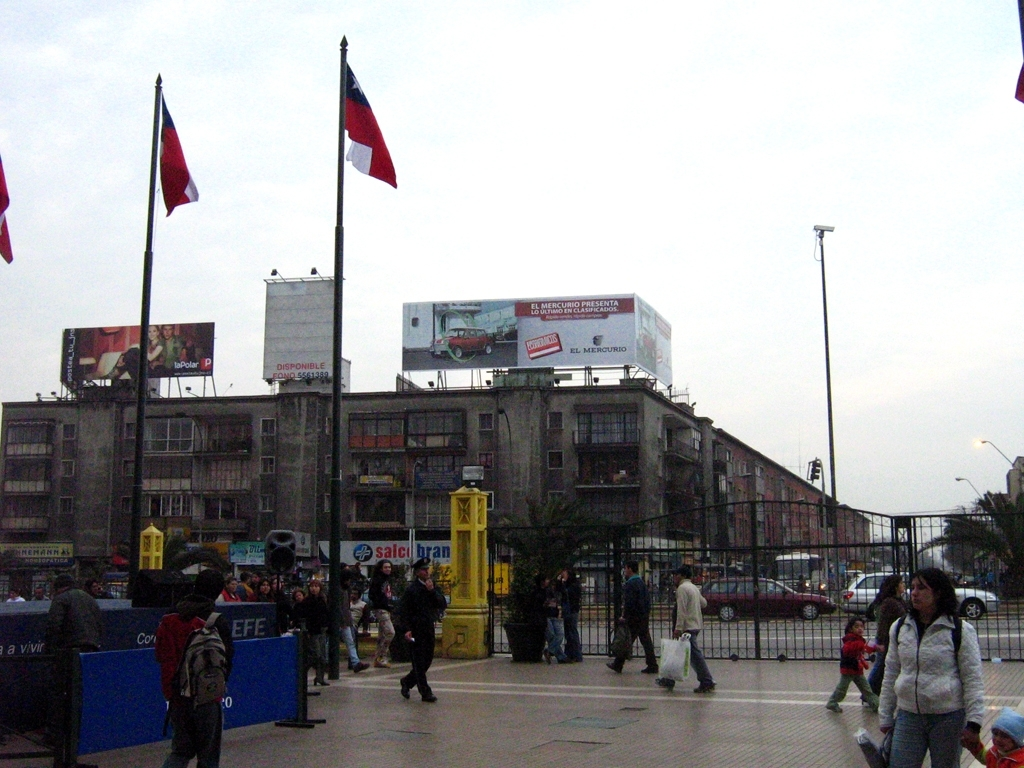What can you infer about the urban environment from this image? This urban environment shows signs of dense living conditions with older, multi-story residential buildings. The large billboards and advertisements suggest commercial activity and appeal to a large pedestrian audience. Moreover, the infrastructure like the traffic lights and zebra crossings indicates a well-planned urban area. What does the advertising presence say about consumer culture in this area? The prominent advertising presence, with large billboards and numerous ads, points to a strong consumer culture. It suggests that this area has a high footfall and is a key spot for businesses to engage with potential customers. This marketing strategy targets the daily commuters and pedestrians who frequent this area. 